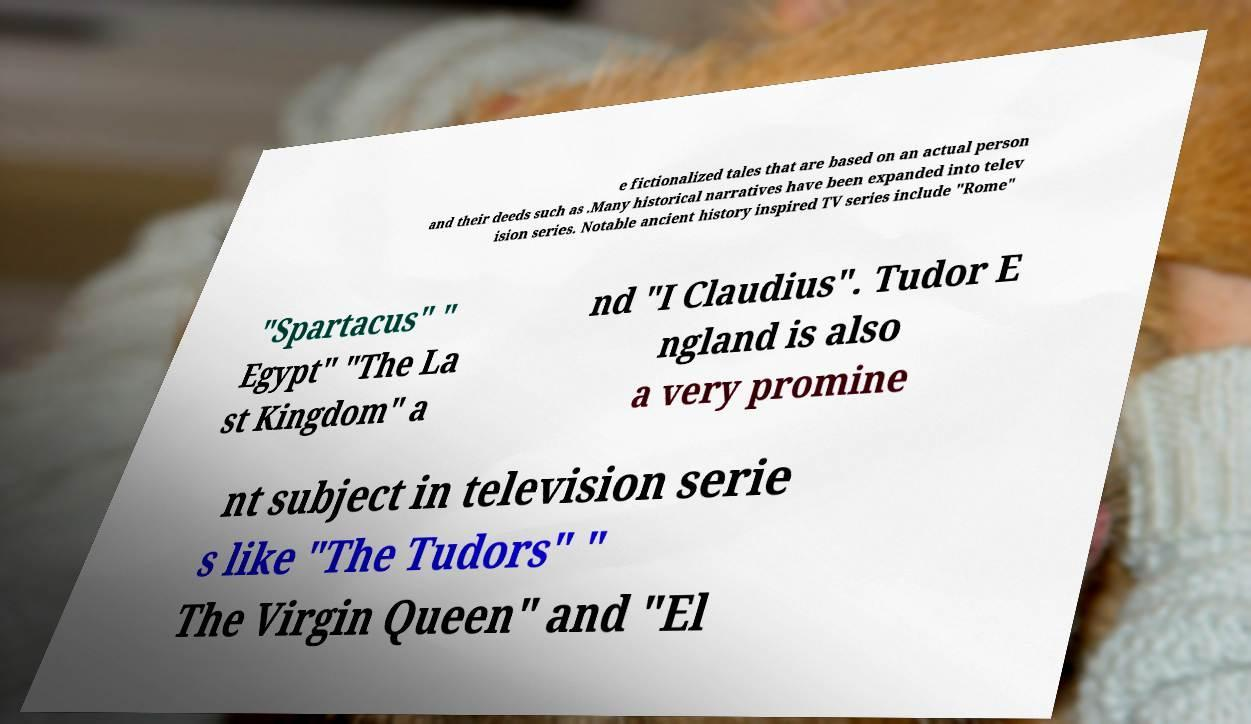There's text embedded in this image that I need extracted. Can you transcribe it verbatim? e fictionalized tales that are based on an actual person and their deeds such as .Many historical narratives have been expanded into telev ision series. Notable ancient history inspired TV series include "Rome" "Spartacus" " Egypt" "The La st Kingdom" a nd "I Claudius". Tudor E ngland is also a very promine nt subject in television serie s like "The Tudors" " The Virgin Queen" and "El 